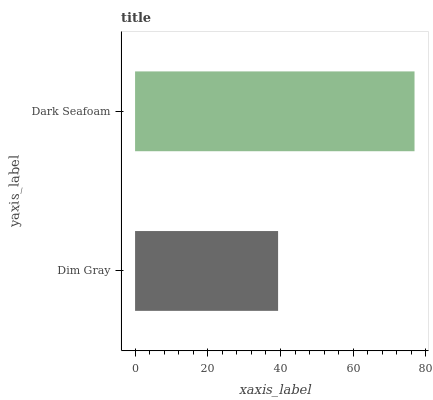Is Dim Gray the minimum?
Answer yes or no. Yes. Is Dark Seafoam the maximum?
Answer yes or no. Yes. Is Dark Seafoam the minimum?
Answer yes or no. No. Is Dark Seafoam greater than Dim Gray?
Answer yes or no. Yes. Is Dim Gray less than Dark Seafoam?
Answer yes or no. Yes. Is Dim Gray greater than Dark Seafoam?
Answer yes or no. No. Is Dark Seafoam less than Dim Gray?
Answer yes or no. No. Is Dark Seafoam the high median?
Answer yes or no. Yes. Is Dim Gray the low median?
Answer yes or no. Yes. Is Dim Gray the high median?
Answer yes or no. No. Is Dark Seafoam the low median?
Answer yes or no. No. 